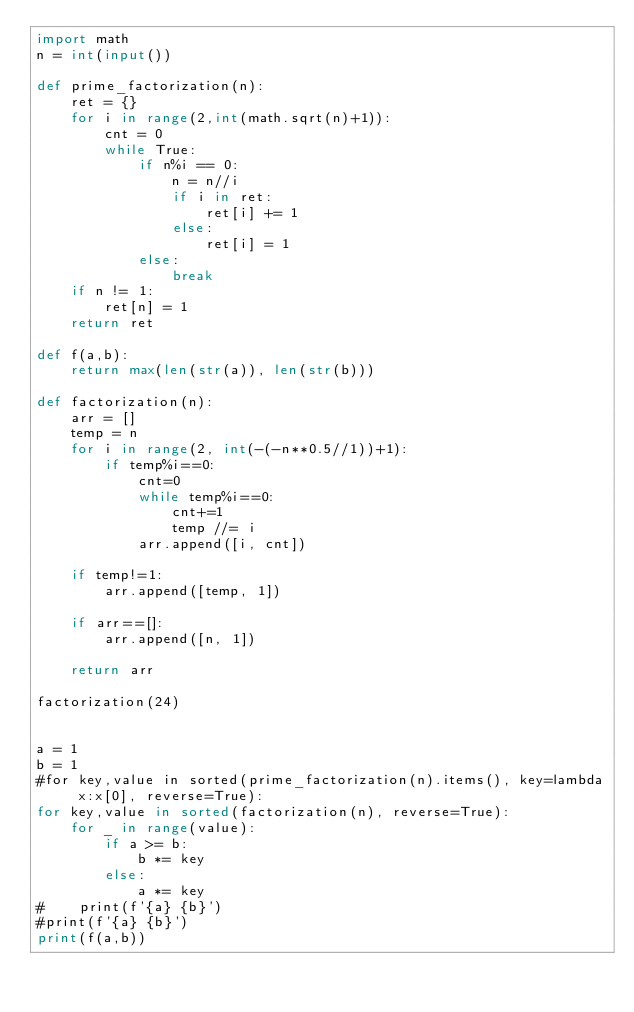Convert code to text. <code><loc_0><loc_0><loc_500><loc_500><_Python_>import math
n = int(input())

def prime_factorization(n):
    ret = {}
    for i in range(2,int(math.sqrt(n)+1)):
        cnt = 0
        while True:
            if n%i == 0:
                n = n//i
                if i in ret:
                    ret[i] += 1
                else:
                    ret[i] = 1
            else:
                break
    if n != 1:
        ret[n] = 1
    return ret

def f(a,b):
    return max(len(str(a)), len(str(b)))

def factorization(n):
    arr = []
    temp = n
    for i in range(2, int(-(-n**0.5//1))+1):
        if temp%i==0:
            cnt=0
            while temp%i==0:
                cnt+=1
                temp //= i
            arr.append([i, cnt])

    if temp!=1:
        arr.append([temp, 1])

    if arr==[]:
        arr.append([n, 1])

    return arr

factorization(24)


a = 1
b = 1
#for key,value in sorted(prime_factorization(n).items(), key=lambda x:x[0], reverse=True):
for key,value in sorted(factorization(n), reverse=True):
    for _ in range(value):
        if a >= b:
            b *= key
        else:
            a *= key
#    print(f'{a} {b}')
#print(f'{a} {b}')
print(f(a,b))</code> 